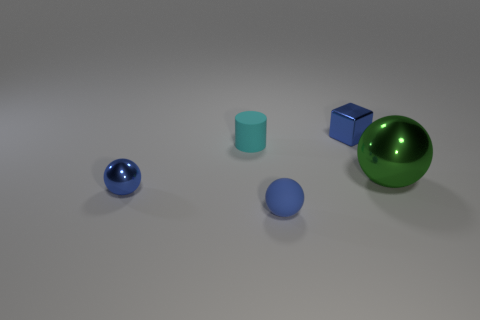Add 3 cyan spheres. How many objects exist? 8 Subtract all cylinders. How many objects are left? 4 Subtract all tiny red rubber cylinders. Subtract all big shiny things. How many objects are left? 4 Add 4 green metal things. How many green metal things are left? 5 Add 2 gray matte blocks. How many gray matte blocks exist? 2 Subtract 0 yellow cubes. How many objects are left? 5 